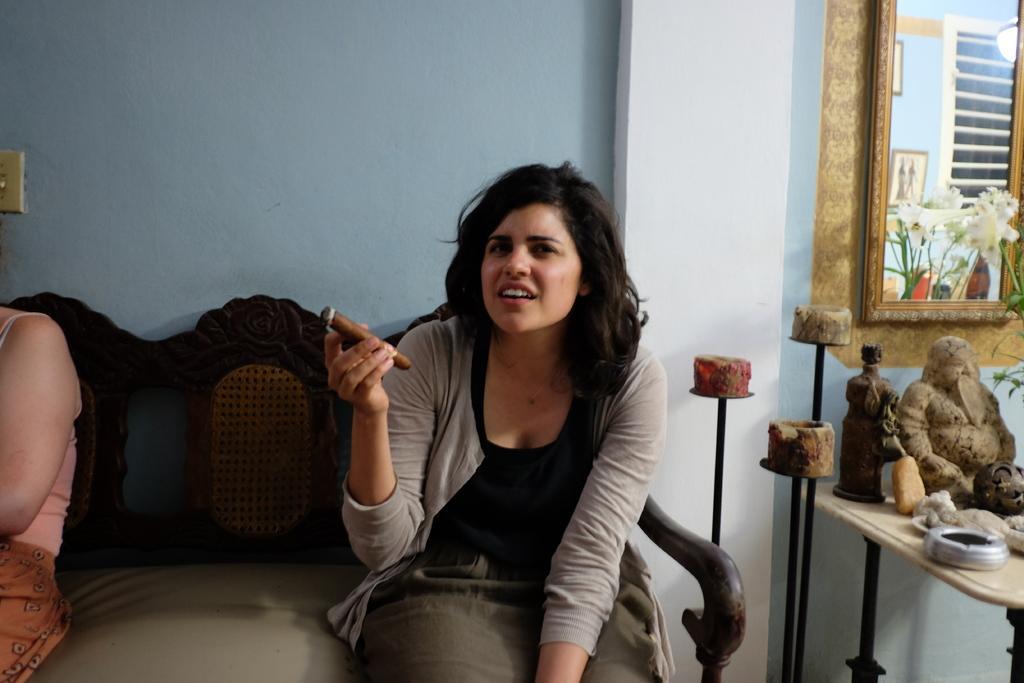Can you describe this image briefly? There is a woman in gray color jacket, holding an object with one hand and sitting on a sofa, on which, there is another person sitting. On the right side, there are statues and other objects on the table, near three stands which are near a mirror on the blue color wall, which is near a white color pillar. Back to the sofa, there is a blue color wall. 